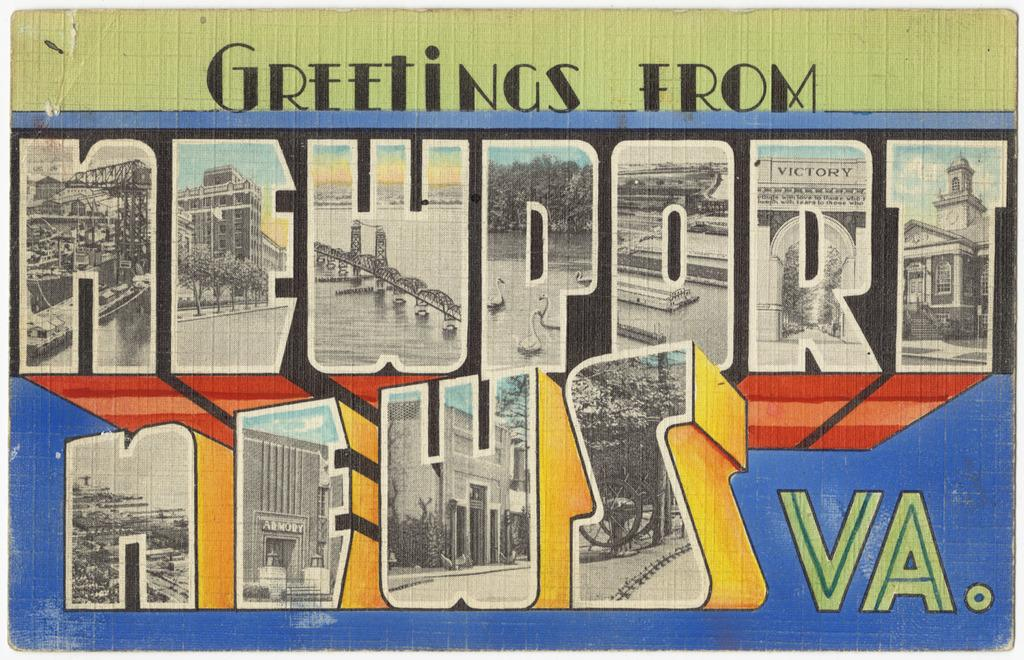<image>
Give a short and clear explanation of the subsequent image. A postcard that reads Greetings from Newport News VA 